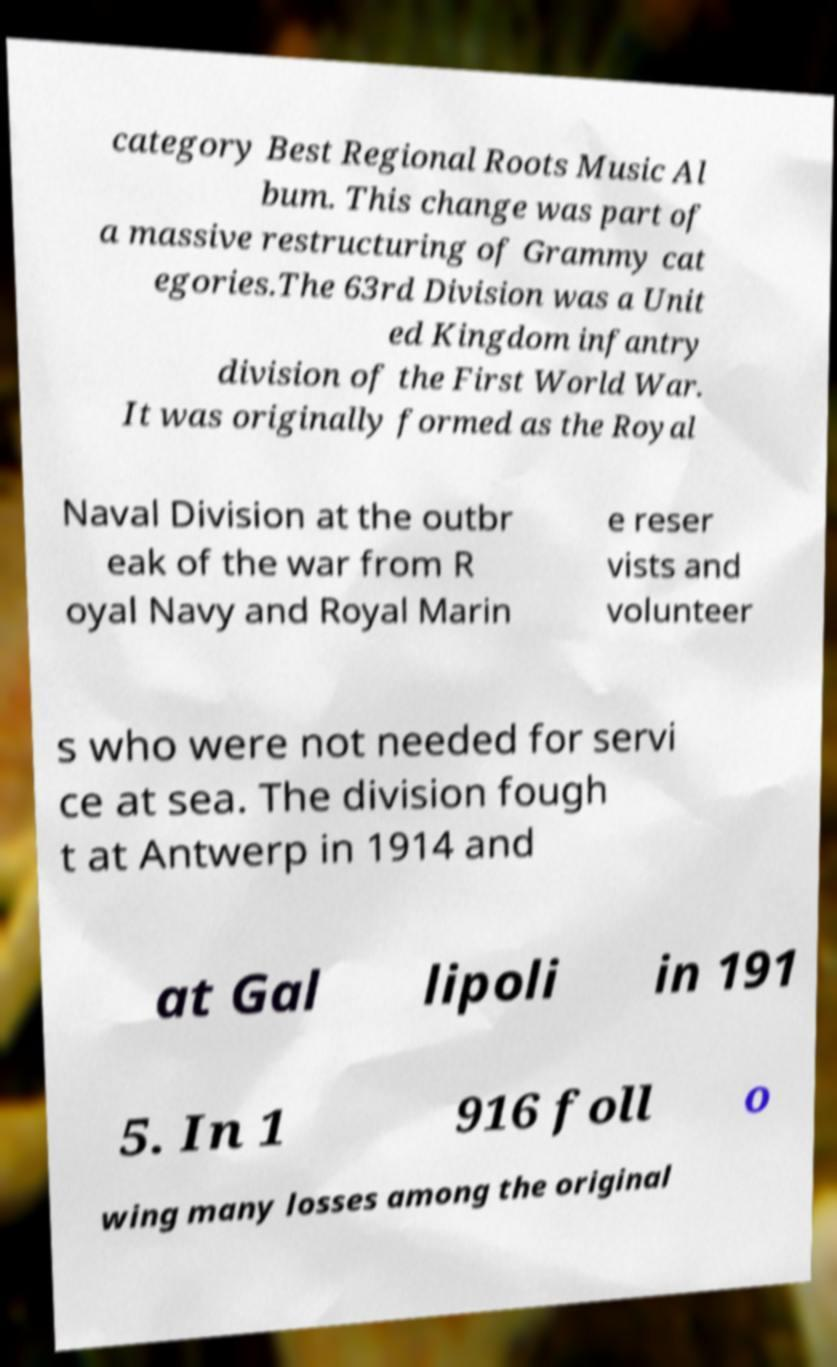Could you assist in decoding the text presented in this image and type it out clearly? category Best Regional Roots Music Al bum. This change was part of a massive restructuring of Grammy cat egories.The 63rd Division was a Unit ed Kingdom infantry division of the First World War. It was originally formed as the Royal Naval Division at the outbr eak of the war from R oyal Navy and Royal Marin e reser vists and volunteer s who were not needed for servi ce at sea. The division fough t at Antwerp in 1914 and at Gal lipoli in 191 5. In 1 916 foll o wing many losses among the original 